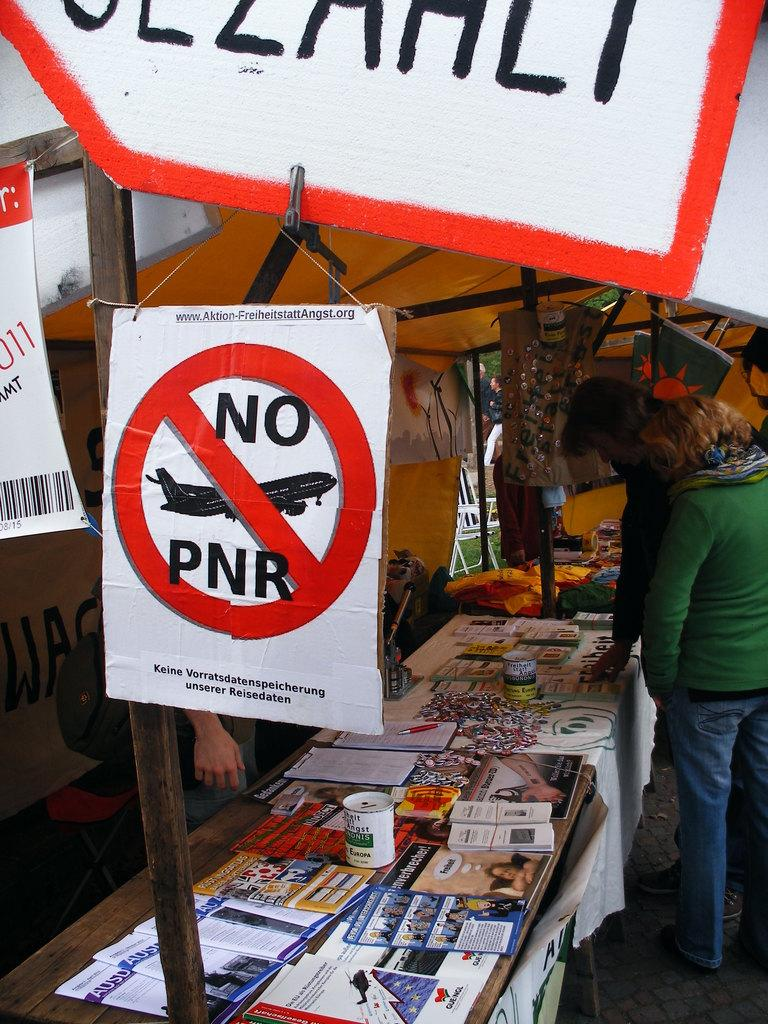<image>
Describe the image concisely. A jar collecting money for Europa at a fleat market. 